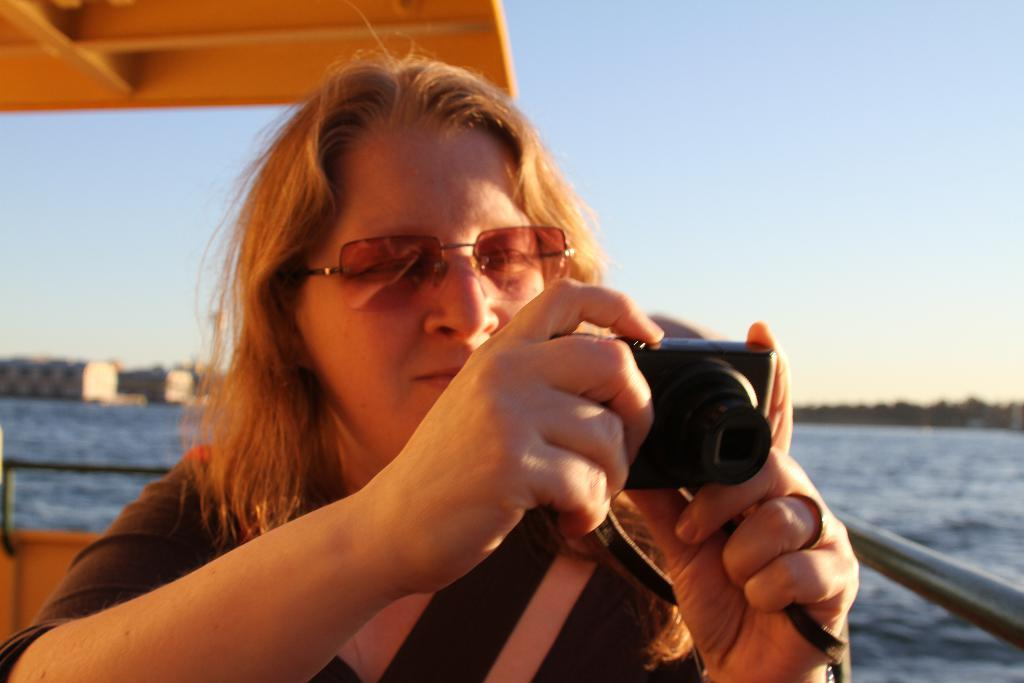Who is the main subject in the image? There is a woman in the image. Can you describe the woman's appearance? The woman has short hair. What is the woman holding in the image? The woman is holding a camera. What can be seen in the background of the image? There is water and the sky visible in the background of the image. What type of can is visible in the image? There is no can present in the image. Can you tell me how many members are in the committee shown in the image? There is no committee present in the image. 